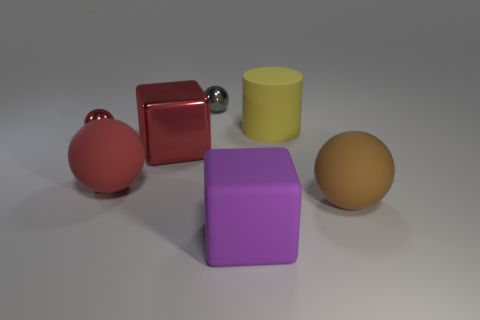Is the shape of the large red shiny object the same as the small object that is in front of the big yellow rubber cylinder?
Your answer should be very brief. No. What is the small red ball made of?
Your response must be concise. Metal. How many shiny objects are either large spheres or yellow objects?
Offer a terse response. 0. Is the number of large red metal blocks behind the small red thing less than the number of purple things that are behind the big purple block?
Your response must be concise. No. Are there any big purple rubber things that are left of the red shiny thing in front of the thing that is on the left side of the large red rubber object?
Give a very brief answer. No. There is a small object that is the same color as the large metal object; what is it made of?
Offer a terse response. Metal. There is a large red object right of the red rubber object; does it have the same shape as the thing that is on the right side of the big yellow matte thing?
Your response must be concise. No. There is a sphere that is the same size as the gray shiny object; what material is it?
Keep it short and to the point. Metal. Are the big ball that is to the right of the purple thing and the small sphere that is in front of the gray metal thing made of the same material?
Offer a terse response. No. What is the shape of the purple thing that is the same size as the metallic cube?
Offer a very short reply. Cube. 